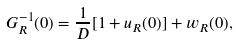Convert formula to latex. <formula><loc_0><loc_0><loc_500><loc_500>G ^ { - 1 } _ { R } ( 0 ) = \frac { 1 } { D } [ 1 + u _ { R } ( 0 ) ] + w _ { R } ( 0 ) ,</formula> 